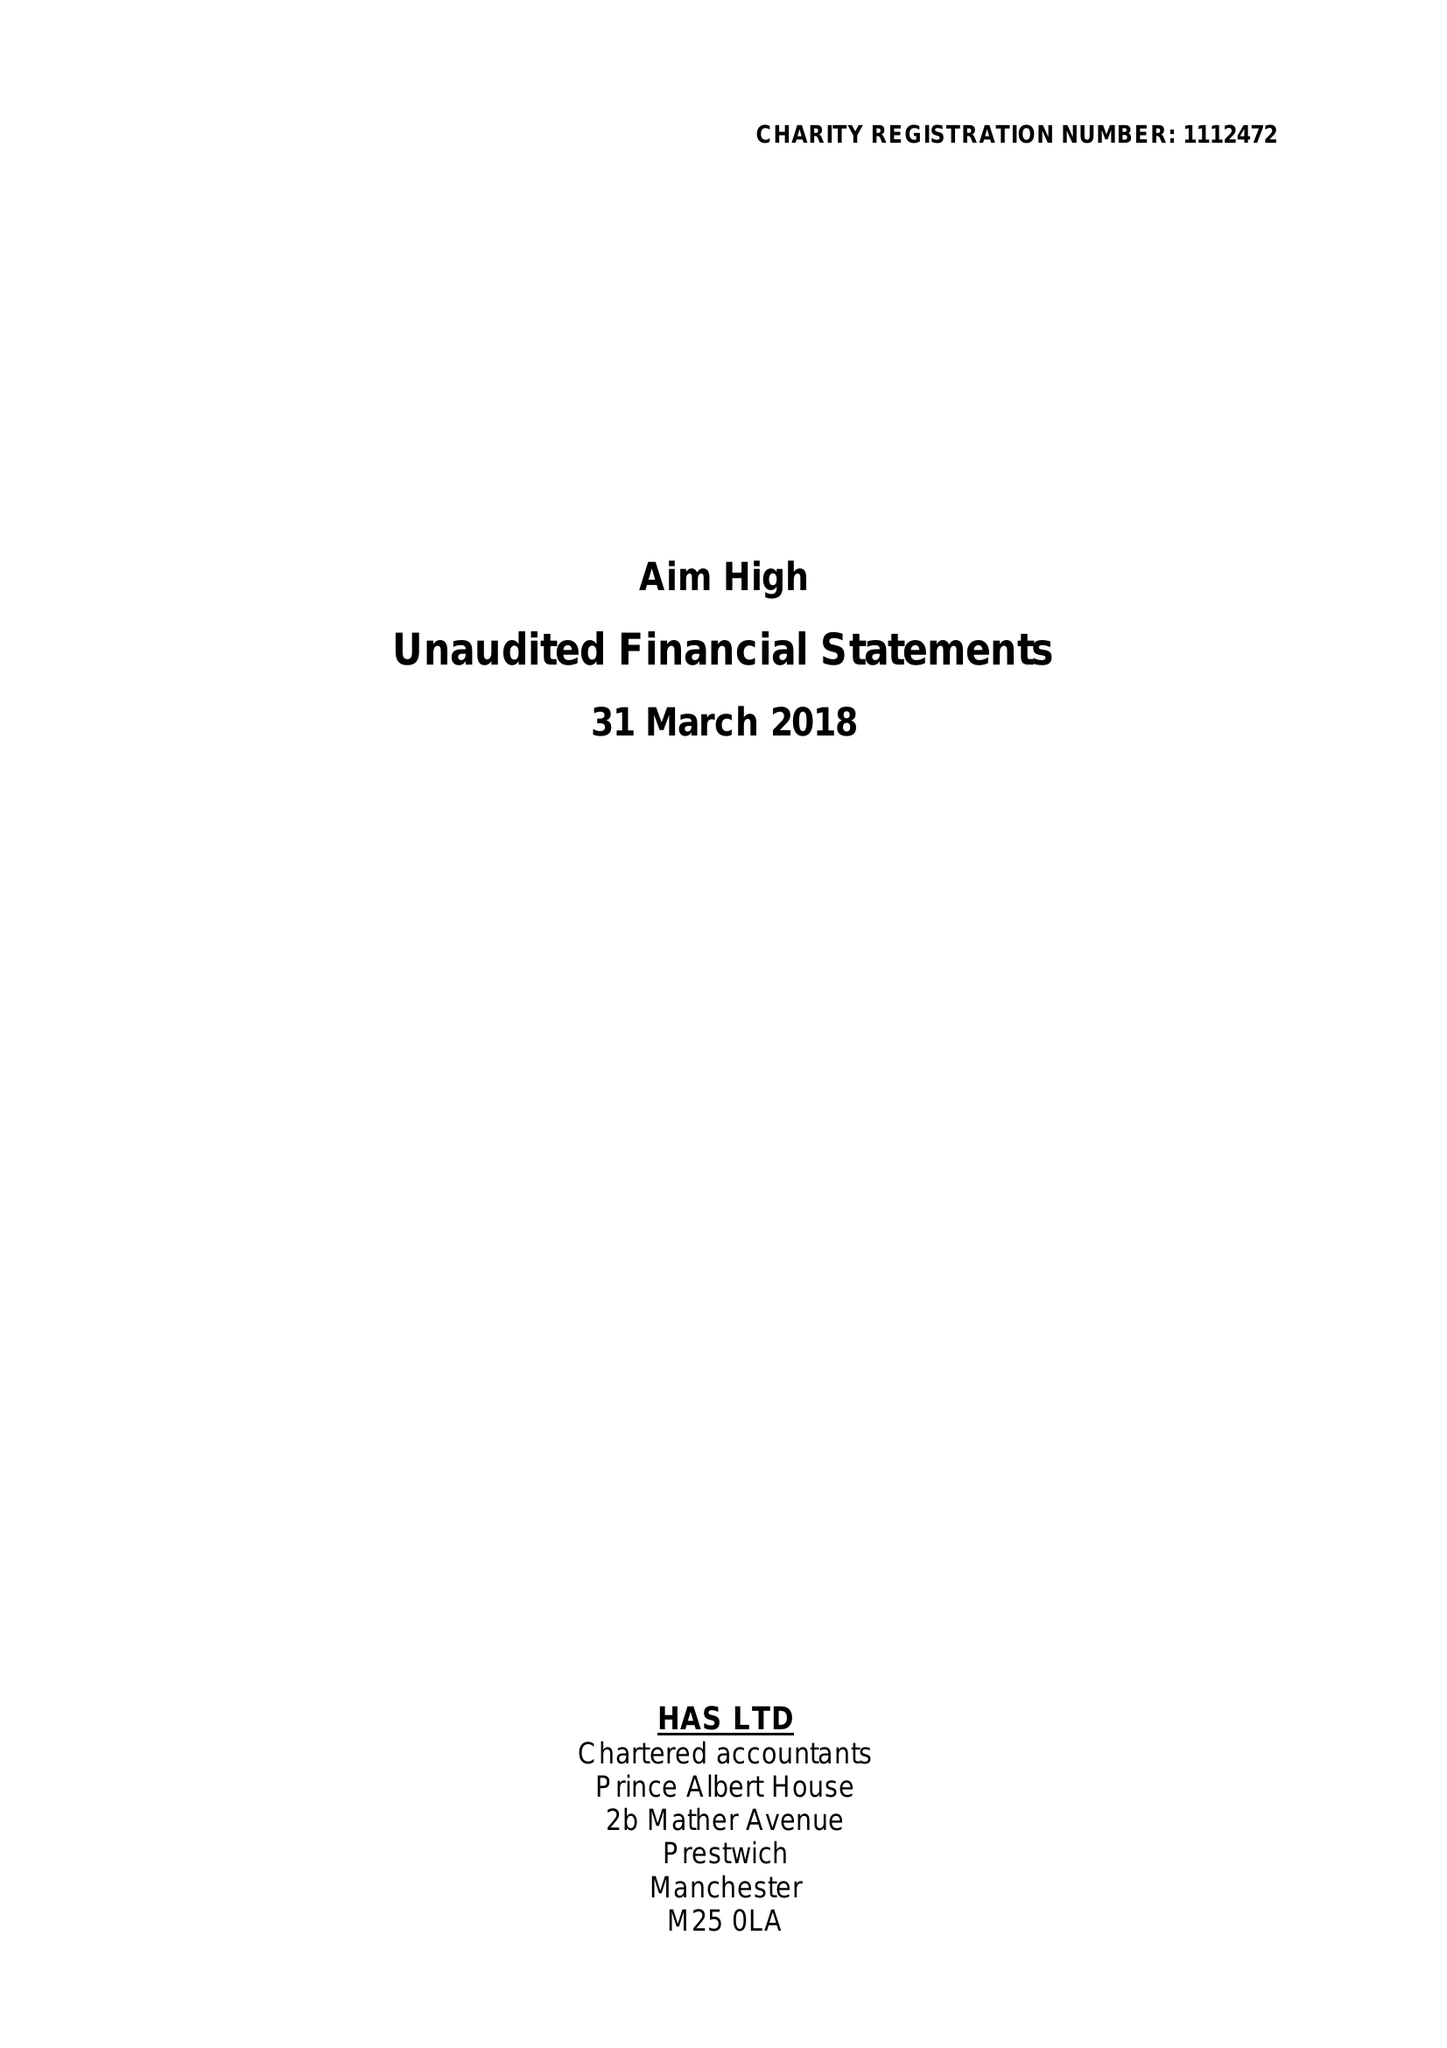What is the value for the report_date?
Answer the question using a single word or phrase. 2018-03-31 